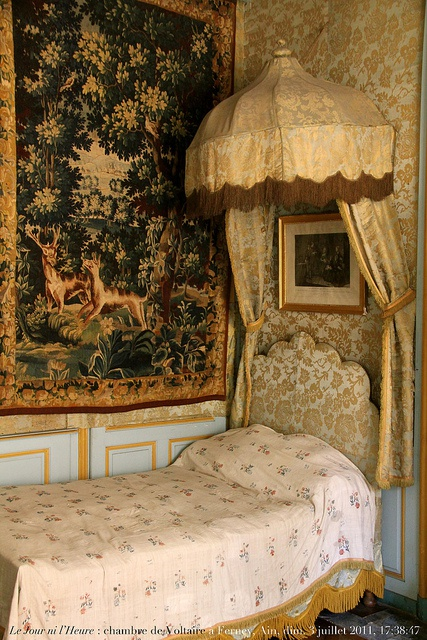Describe the objects in this image and their specific colors. I can see a bed in black, lightgray, and tan tones in this image. 